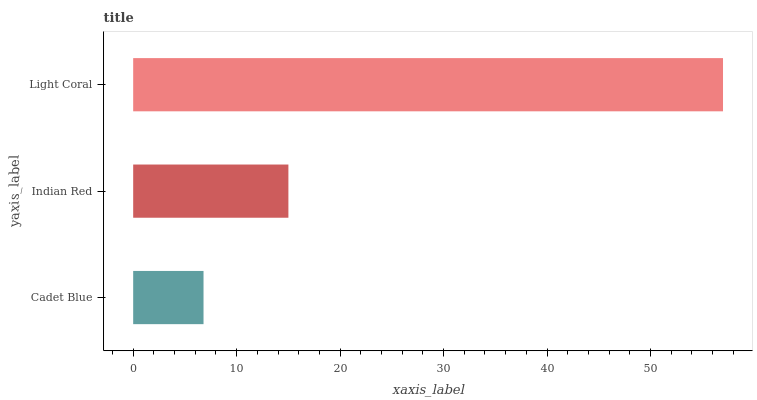Is Cadet Blue the minimum?
Answer yes or no. Yes. Is Light Coral the maximum?
Answer yes or no. Yes. Is Indian Red the minimum?
Answer yes or no. No. Is Indian Red the maximum?
Answer yes or no. No. Is Indian Red greater than Cadet Blue?
Answer yes or no. Yes. Is Cadet Blue less than Indian Red?
Answer yes or no. Yes. Is Cadet Blue greater than Indian Red?
Answer yes or no. No. Is Indian Red less than Cadet Blue?
Answer yes or no. No. Is Indian Red the high median?
Answer yes or no. Yes. Is Indian Red the low median?
Answer yes or no. Yes. Is Cadet Blue the high median?
Answer yes or no. No. Is Cadet Blue the low median?
Answer yes or no. No. 